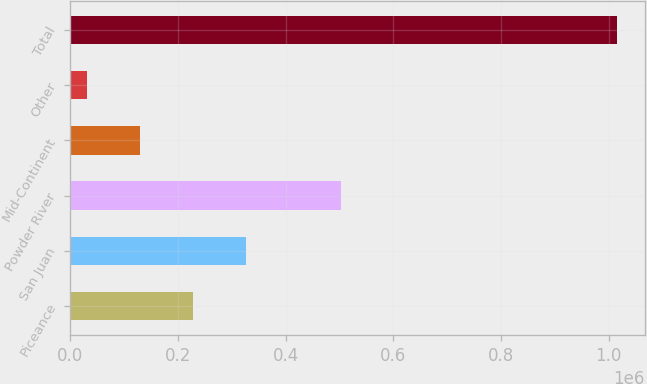Convert chart to OTSL. <chart><loc_0><loc_0><loc_500><loc_500><bar_chart><fcel>Piceance<fcel>San Juan<fcel>Powder River<fcel>Mid-Continent<fcel>Other<fcel>Total<nl><fcel>227313<fcel>325955<fcel>502455<fcel>128671<fcel>30029<fcel>1.01645e+06<nl></chart> 